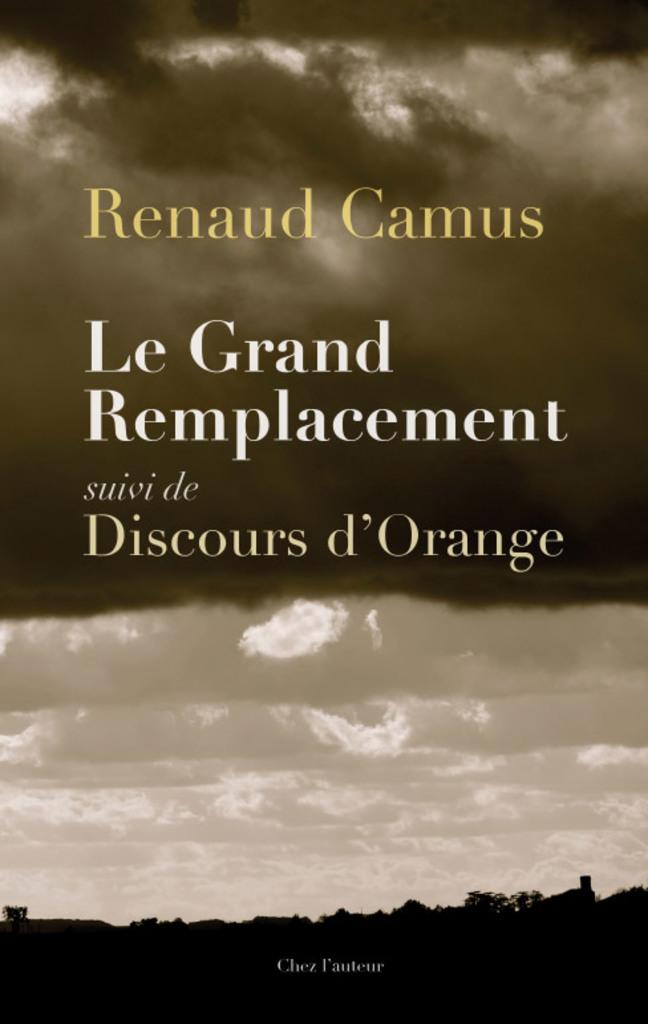What is featured in the image? There is a poster in the image. What can be found on the poster? There is text on the poster. Can you describe the background of the image? The background of the image has white, brown, and black colors. What type of crayon is being used to write on the poster in the image? There is no crayon present in the image, and no writing is being done on the poster. Is there a fowl visible in the image? No, there is no fowl present in the image. 